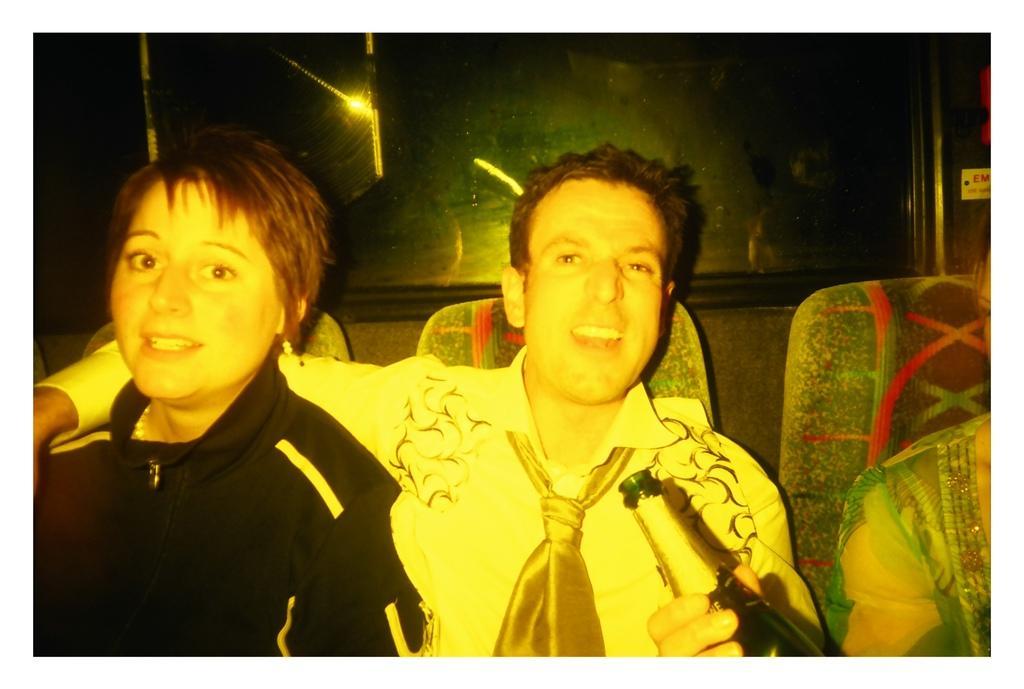Can you describe this image briefly? In this image there are three people sitting on their chairs, behind them there is a wall with glass window. 